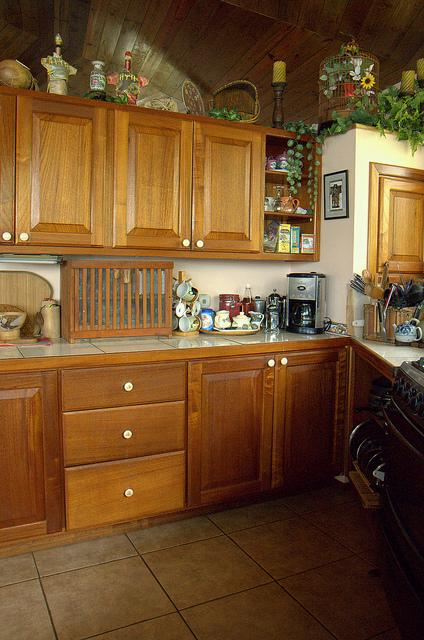How many drawers are in the bottom cabinet of this kitchen? Please explain your reasoning. three. They are part of the cabinets and easy to count 